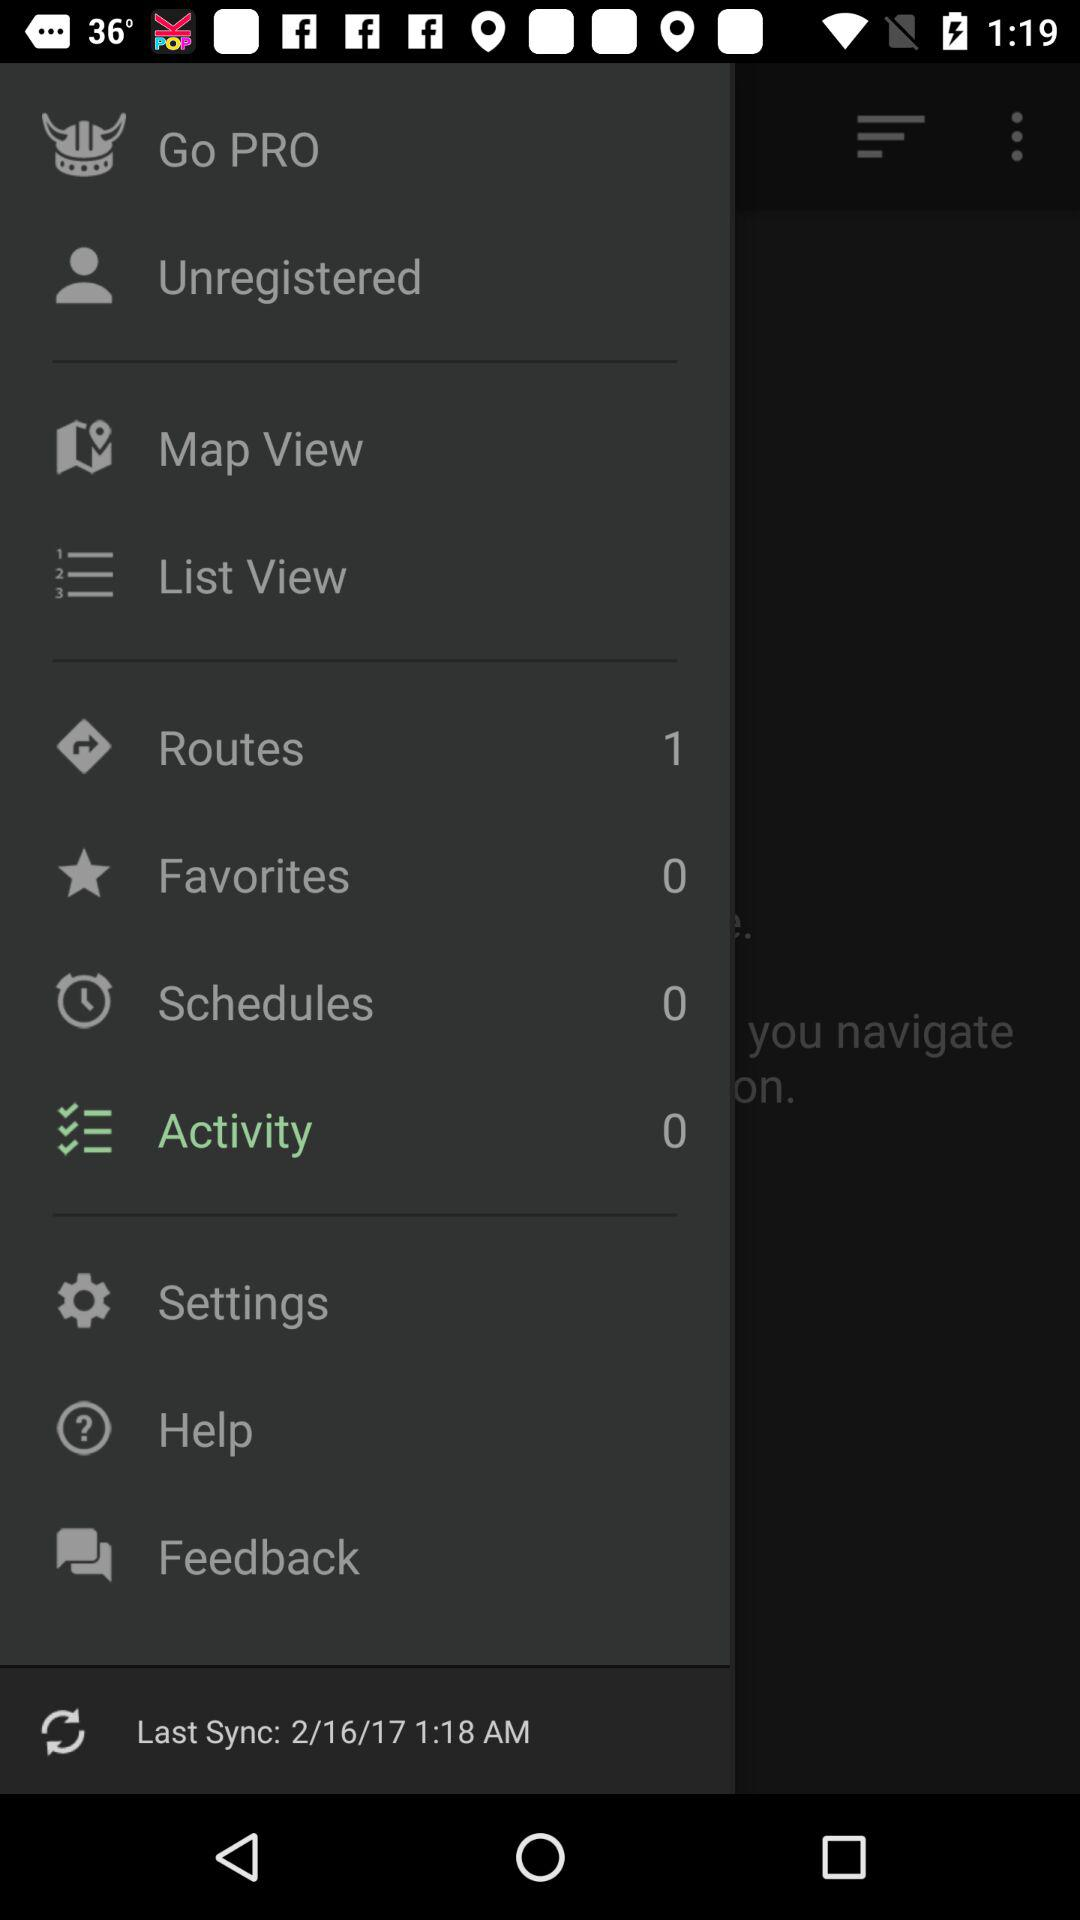How many items are there in "Schedules"? There are 0 items in "Schedules". 